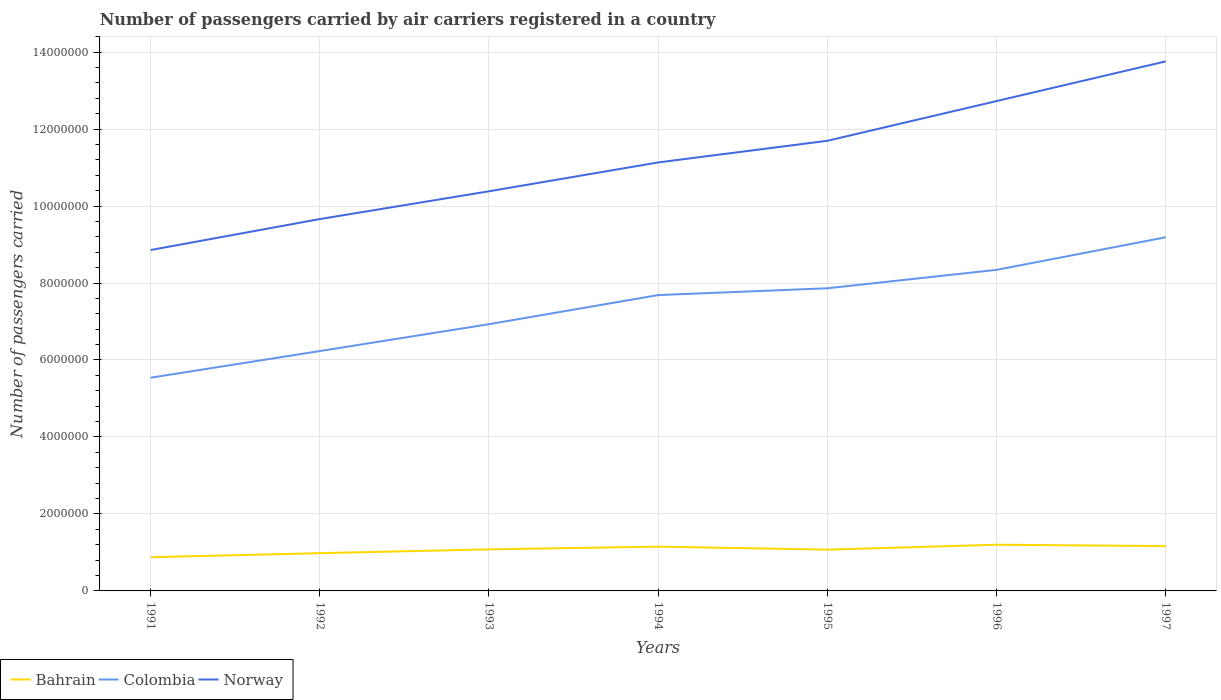How many different coloured lines are there?
Provide a short and direct response. 3. Does the line corresponding to Bahrain intersect with the line corresponding to Norway?
Your response must be concise. No. Across all years, what is the maximum number of passengers carried by air carriers in Norway?
Your answer should be compact. 8.86e+06. What is the total number of passengers carried by air carriers in Bahrain in the graph?
Provide a succinct answer. 3.57e+04. What is the difference between the highest and the second highest number of passengers carried by air carriers in Bahrain?
Provide a short and direct response. 3.25e+05. What is the difference between the highest and the lowest number of passengers carried by air carriers in Colombia?
Offer a terse response. 4. Is the number of passengers carried by air carriers in Norway strictly greater than the number of passengers carried by air carriers in Bahrain over the years?
Your answer should be very brief. No. How many lines are there?
Provide a short and direct response. 3. How many years are there in the graph?
Your answer should be very brief. 7. Does the graph contain any zero values?
Ensure brevity in your answer.  No. Does the graph contain grids?
Offer a very short reply. Yes. How are the legend labels stacked?
Your answer should be very brief. Horizontal. What is the title of the graph?
Provide a short and direct response. Number of passengers carried by air carriers registered in a country. Does "Greece" appear as one of the legend labels in the graph?
Make the answer very short. No. What is the label or title of the X-axis?
Your answer should be very brief. Years. What is the label or title of the Y-axis?
Keep it short and to the point. Number of passengers carried. What is the Number of passengers carried of Bahrain in 1991?
Your answer should be compact. 8.76e+05. What is the Number of passengers carried in Colombia in 1991?
Ensure brevity in your answer.  5.54e+06. What is the Number of passengers carried in Norway in 1991?
Offer a very short reply. 8.86e+06. What is the Number of passengers carried of Bahrain in 1992?
Keep it short and to the point. 9.81e+05. What is the Number of passengers carried of Colombia in 1992?
Your answer should be compact. 6.23e+06. What is the Number of passengers carried in Norway in 1992?
Your response must be concise. 9.66e+06. What is the Number of passengers carried in Bahrain in 1993?
Ensure brevity in your answer.  1.08e+06. What is the Number of passengers carried of Colombia in 1993?
Your answer should be very brief. 6.93e+06. What is the Number of passengers carried of Norway in 1993?
Your response must be concise. 1.04e+07. What is the Number of passengers carried of Bahrain in 1994?
Ensure brevity in your answer.  1.15e+06. What is the Number of passengers carried of Colombia in 1994?
Offer a terse response. 7.69e+06. What is the Number of passengers carried in Norway in 1994?
Your response must be concise. 1.11e+07. What is the Number of passengers carried in Bahrain in 1995?
Offer a terse response. 1.07e+06. What is the Number of passengers carried in Colombia in 1995?
Offer a terse response. 7.86e+06. What is the Number of passengers carried of Norway in 1995?
Ensure brevity in your answer.  1.17e+07. What is the Number of passengers carried in Bahrain in 1996?
Give a very brief answer. 1.20e+06. What is the Number of passengers carried in Colombia in 1996?
Your response must be concise. 8.34e+06. What is the Number of passengers carried of Norway in 1996?
Your response must be concise. 1.27e+07. What is the Number of passengers carried of Bahrain in 1997?
Your response must be concise. 1.16e+06. What is the Number of passengers carried in Colombia in 1997?
Make the answer very short. 9.19e+06. What is the Number of passengers carried in Norway in 1997?
Give a very brief answer. 1.38e+07. Across all years, what is the maximum Number of passengers carried of Bahrain?
Offer a very short reply. 1.20e+06. Across all years, what is the maximum Number of passengers carried in Colombia?
Keep it short and to the point. 9.19e+06. Across all years, what is the maximum Number of passengers carried of Norway?
Provide a short and direct response. 1.38e+07. Across all years, what is the minimum Number of passengers carried in Bahrain?
Keep it short and to the point. 8.76e+05. Across all years, what is the minimum Number of passengers carried in Colombia?
Your answer should be very brief. 5.54e+06. Across all years, what is the minimum Number of passengers carried of Norway?
Your answer should be very brief. 8.86e+06. What is the total Number of passengers carried in Bahrain in the graph?
Give a very brief answer. 7.52e+06. What is the total Number of passengers carried of Colombia in the graph?
Offer a very short reply. 5.18e+07. What is the total Number of passengers carried in Norway in the graph?
Your answer should be very brief. 7.82e+07. What is the difference between the Number of passengers carried of Bahrain in 1991 and that in 1992?
Keep it short and to the point. -1.06e+05. What is the difference between the Number of passengers carried of Colombia in 1991 and that in 1992?
Your response must be concise. -6.92e+05. What is the difference between the Number of passengers carried of Norway in 1991 and that in 1992?
Give a very brief answer. -8.04e+05. What is the difference between the Number of passengers carried in Bahrain in 1991 and that in 1993?
Ensure brevity in your answer.  -2.04e+05. What is the difference between the Number of passengers carried in Colombia in 1991 and that in 1993?
Offer a very short reply. -1.39e+06. What is the difference between the Number of passengers carried in Norway in 1991 and that in 1993?
Offer a very short reply. -1.53e+06. What is the difference between the Number of passengers carried in Bahrain in 1991 and that in 1994?
Your answer should be compact. -2.75e+05. What is the difference between the Number of passengers carried in Colombia in 1991 and that in 1994?
Provide a short and direct response. -2.15e+06. What is the difference between the Number of passengers carried of Norway in 1991 and that in 1994?
Offer a very short reply. -2.28e+06. What is the difference between the Number of passengers carried of Bahrain in 1991 and that in 1995?
Give a very brief answer. -1.97e+05. What is the difference between the Number of passengers carried in Colombia in 1991 and that in 1995?
Give a very brief answer. -2.32e+06. What is the difference between the Number of passengers carried in Norway in 1991 and that in 1995?
Offer a terse response. -2.84e+06. What is the difference between the Number of passengers carried of Bahrain in 1991 and that in 1996?
Ensure brevity in your answer.  -3.25e+05. What is the difference between the Number of passengers carried in Colombia in 1991 and that in 1996?
Ensure brevity in your answer.  -2.80e+06. What is the difference between the Number of passengers carried of Norway in 1991 and that in 1996?
Your response must be concise. -3.87e+06. What is the difference between the Number of passengers carried of Bahrain in 1991 and that in 1997?
Ensure brevity in your answer.  -2.89e+05. What is the difference between the Number of passengers carried in Colombia in 1991 and that in 1997?
Offer a very short reply. -3.65e+06. What is the difference between the Number of passengers carried of Norway in 1991 and that in 1997?
Your answer should be very brief. -4.90e+06. What is the difference between the Number of passengers carried in Bahrain in 1992 and that in 1993?
Ensure brevity in your answer.  -9.89e+04. What is the difference between the Number of passengers carried of Colombia in 1992 and that in 1993?
Your answer should be compact. -6.98e+05. What is the difference between the Number of passengers carried of Norway in 1992 and that in 1993?
Keep it short and to the point. -7.22e+05. What is the difference between the Number of passengers carried in Bahrain in 1992 and that in 1994?
Offer a very short reply. -1.70e+05. What is the difference between the Number of passengers carried in Colombia in 1992 and that in 1994?
Your answer should be very brief. -1.45e+06. What is the difference between the Number of passengers carried of Norway in 1992 and that in 1994?
Your answer should be very brief. -1.47e+06. What is the difference between the Number of passengers carried in Bahrain in 1992 and that in 1995?
Ensure brevity in your answer.  -9.14e+04. What is the difference between the Number of passengers carried of Colombia in 1992 and that in 1995?
Your response must be concise. -1.63e+06. What is the difference between the Number of passengers carried in Norway in 1992 and that in 1995?
Keep it short and to the point. -2.03e+06. What is the difference between the Number of passengers carried in Bahrain in 1992 and that in 1996?
Your response must be concise. -2.19e+05. What is the difference between the Number of passengers carried of Colombia in 1992 and that in 1996?
Your answer should be very brief. -2.11e+06. What is the difference between the Number of passengers carried in Norway in 1992 and that in 1996?
Ensure brevity in your answer.  -3.07e+06. What is the difference between the Number of passengers carried in Bahrain in 1992 and that in 1997?
Provide a succinct answer. -1.84e+05. What is the difference between the Number of passengers carried in Colombia in 1992 and that in 1997?
Your answer should be compact. -2.96e+06. What is the difference between the Number of passengers carried of Norway in 1992 and that in 1997?
Offer a very short reply. -4.10e+06. What is the difference between the Number of passengers carried in Bahrain in 1993 and that in 1994?
Provide a short and direct response. -7.06e+04. What is the difference between the Number of passengers carried in Colombia in 1993 and that in 1994?
Your answer should be compact. -7.56e+05. What is the difference between the Number of passengers carried in Norway in 1993 and that in 1994?
Offer a terse response. -7.50e+05. What is the difference between the Number of passengers carried in Bahrain in 1993 and that in 1995?
Provide a succinct answer. 7500. What is the difference between the Number of passengers carried in Colombia in 1993 and that in 1995?
Your response must be concise. -9.33e+05. What is the difference between the Number of passengers carried in Norway in 1993 and that in 1995?
Your answer should be compact. -1.31e+06. What is the difference between the Number of passengers carried of Bahrain in 1993 and that in 1996?
Keep it short and to the point. -1.20e+05. What is the difference between the Number of passengers carried in Colombia in 1993 and that in 1996?
Give a very brief answer. -1.41e+06. What is the difference between the Number of passengers carried in Norway in 1993 and that in 1996?
Your response must be concise. -2.34e+06. What is the difference between the Number of passengers carried of Bahrain in 1993 and that in 1997?
Provide a succinct answer. -8.46e+04. What is the difference between the Number of passengers carried of Colombia in 1993 and that in 1997?
Your answer should be very brief. -2.26e+06. What is the difference between the Number of passengers carried in Norway in 1993 and that in 1997?
Your answer should be compact. -3.38e+06. What is the difference between the Number of passengers carried of Bahrain in 1994 and that in 1995?
Give a very brief answer. 7.81e+04. What is the difference between the Number of passengers carried of Colombia in 1994 and that in 1995?
Ensure brevity in your answer.  -1.77e+05. What is the difference between the Number of passengers carried in Norway in 1994 and that in 1995?
Give a very brief answer. -5.62e+05. What is the difference between the Number of passengers carried in Bahrain in 1994 and that in 1996?
Provide a succinct answer. -4.97e+04. What is the difference between the Number of passengers carried in Colombia in 1994 and that in 1996?
Your response must be concise. -6.56e+05. What is the difference between the Number of passengers carried of Norway in 1994 and that in 1996?
Your answer should be very brief. -1.59e+06. What is the difference between the Number of passengers carried in Bahrain in 1994 and that in 1997?
Your answer should be very brief. -1.40e+04. What is the difference between the Number of passengers carried of Colombia in 1994 and that in 1997?
Your answer should be very brief. -1.50e+06. What is the difference between the Number of passengers carried of Norway in 1994 and that in 1997?
Make the answer very short. -2.63e+06. What is the difference between the Number of passengers carried in Bahrain in 1995 and that in 1996?
Ensure brevity in your answer.  -1.28e+05. What is the difference between the Number of passengers carried of Colombia in 1995 and that in 1996?
Your response must be concise. -4.79e+05. What is the difference between the Number of passengers carried of Norway in 1995 and that in 1996?
Provide a succinct answer. -1.03e+06. What is the difference between the Number of passengers carried of Bahrain in 1995 and that in 1997?
Your answer should be compact. -9.21e+04. What is the difference between the Number of passengers carried in Colombia in 1995 and that in 1997?
Offer a very short reply. -1.33e+06. What is the difference between the Number of passengers carried in Norway in 1995 and that in 1997?
Your response must be concise. -2.06e+06. What is the difference between the Number of passengers carried of Bahrain in 1996 and that in 1997?
Give a very brief answer. 3.57e+04. What is the difference between the Number of passengers carried in Colombia in 1996 and that in 1997?
Offer a terse response. -8.47e+05. What is the difference between the Number of passengers carried of Norway in 1996 and that in 1997?
Keep it short and to the point. -1.03e+06. What is the difference between the Number of passengers carried of Bahrain in 1991 and the Number of passengers carried of Colombia in 1992?
Offer a very short reply. -5.36e+06. What is the difference between the Number of passengers carried in Bahrain in 1991 and the Number of passengers carried in Norway in 1992?
Offer a terse response. -8.79e+06. What is the difference between the Number of passengers carried in Colombia in 1991 and the Number of passengers carried in Norway in 1992?
Keep it short and to the point. -4.12e+06. What is the difference between the Number of passengers carried of Bahrain in 1991 and the Number of passengers carried of Colombia in 1993?
Keep it short and to the point. -6.05e+06. What is the difference between the Number of passengers carried of Bahrain in 1991 and the Number of passengers carried of Norway in 1993?
Your answer should be compact. -9.51e+06. What is the difference between the Number of passengers carried of Colombia in 1991 and the Number of passengers carried of Norway in 1993?
Give a very brief answer. -4.84e+06. What is the difference between the Number of passengers carried of Bahrain in 1991 and the Number of passengers carried of Colombia in 1994?
Keep it short and to the point. -6.81e+06. What is the difference between the Number of passengers carried in Bahrain in 1991 and the Number of passengers carried in Norway in 1994?
Provide a short and direct response. -1.03e+07. What is the difference between the Number of passengers carried of Colombia in 1991 and the Number of passengers carried of Norway in 1994?
Provide a succinct answer. -5.59e+06. What is the difference between the Number of passengers carried of Bahrain in 1991 and the Number of passengers carried of Colombia in 1995?
Provide a succinct answer. -6.99e+06. What is the difference between the Number of passengers carried of Bahrain in 1991 and the Number of passengers carried of Norway in 1995?
Offer a terse response. -1.08e+07. What is the difference between the Number of passengers carried of Colombia in 1991 and the Number of passengers carried of Norway in 1995?
Your response must be concise. -6.16e+06. What is the difference between the Number of passengers carried in Bahrain in 1991 and the Number of passengers carried in Colombia in 1996?
Provide a succinct answer. -7.47e+06. What is the difference between the Number of passengers carried in Bahrain in 1991 and the Number of passengers carried in Norway in 1996?
Provide a short and direct response. -1.19e+07. What is the difference between the Number of passengers carried of Colombia in 1991 and the Number of passengers carried of Norway in 1996?
Make the answer very short. -7.19e+06. What is the difference between the Number of passengers carried in Bahrain in 1991 and the Number of passengers carried in Colombia in 1997?
Offer a very short reply. -8.31e+06. What is the difference between the Number of passengers carried of Bahrain in 1991 and the Number of passengers carried of Norway in 1997?
Offer a terse response. -1.29e+07. What is the difference between the Number of passengers carried of Colombia in 1991 and the Number of passengers carried of Norway in 1997?
Your answer should be compact. -8.22e+06. What is the difference between the Number of passengers carried in Bahrain in 1992 and the Number of passengers carried in Colombia in 1993?
Offer a very short reply. -5.95e+06. What is the difference between the Number of passengers carried in Bahrain in 1992 and the Number of passengers carried in Norway in 1993?
Your response must be concise. -9.40e+06. What is the difference between the Number of passengers carried of Colombia in 1992 and the Number of passengers carried of Norway in 1993?
Ensure brevity in your answer.  -4.15e+06. What is the difference between the Number of passengers carried in Bahrain in 1992 and the Number of passengers carried in Colombia in 1994?
Offer a terse response. -6.71e+06. What is the difference between the Number of passengers carried in Bahrain in 1992 and the Number of passengers carried in Norway in 1994?
Keep it short and to the point. -1.02e+07. What is the difference between the Number of passengers carried in Colombia in 1992 and the Number of passengers carried in Norway in 1994?
Offer a terse response. -4.90e+06. What is the difference between the Number of passengers carried in Bahrain in 1992 and the Number of passengers carried in Colombia in 1995?
Your answer should be very brief. -6.88e+06. What is the difference between the Number of passengers carried of Bahrain in 1992 and the Number of passengers carried of Norway in 1995?
Offer a terse response. -1.07e+07. What is the difference between the Number of passengers carried of Colombia in 1992 and the Number of passengers carried of Norway in 1995?
Your response must be concise. -5.46e+06. What is the difference between the Number of passengers carried of Bahrain in 1992 and the Number of passengers carried of Colombia in 1996?
Offer a terse response. -7.36e+06. What is the difference between the Number of passengers carried of Bahrain in 1992 and the Number of passengers carried of Norway in 1996?
Your answer should be compact. -1.17e+07. What is the difference between the Number of passengers carried in Colombia in 1992 and the Number of passengers carried in Norway in 1996?
Your response must be concise. -6.50e+06. What is the difference between the Number of passengers carried of Bahrain in 1992 and the Number of passengers carried of Colombia in 1997?
Ensure brevity in your answer.  -8.21e+06. What is the difference between the Number of passengers carried in Bahrain in 1992 and the Number of passengers carried in Norway in 1997?
Offer a very short reply. -1.28e+07. What is the difference between the Number of passengers carried of Colombia in 1992 and the Number of passengers carried of Norway in 1997?
Provide a short and direct response. -7.53e+06. What is the difference between the Number of passengers carried of Bahrain in 1993 and the Number of passengers carried of Colombia in 1994?
Your answer should be compact. -6.61e+06. What is the difference between the Number of passengers carried of Bahrain in 1993 and the Number of passengers carried of Norway in 1994?
Give a very brief answer. -1.01e+07. What is the difference between the Number of passengers carried of Colombia in 1993 and the Number of passengers carried of Norway in 1994?
Give a very brief answer. -4.20e+06. What is the difference between the Number of passengers carried of Bahrain in 1993 and the Number of passengers carried of Colombia in 1995?
Your answer should be very brief. -6.78e+06. What is the difference between the Number of passengers carried of Bahrain in 1993 and the Number of passengers carried of Norway in 1995?
Offer a terse response. -1.06e+07. What is the difference between the Number of passengers carried of Colombia in 1993 and the Number of passengers carried of Norway in 1995?
Keep it short and to the point. -4.77e+06. What is the difference between the Number of passengers carried in Bahrain in 1993 and the Number of passengers carried in Colombia in 1996?
Your answer should be very brief. -7.26e+06. What is the difference between the Number of passengers carried in Bahrain in 1993 and the Number of passengers carried in Norway in 1996?
Your response must be concise. -1.16e+07. What is the difference between the Number of passengers carried in Colombia in 1993 and the Number of passengers carried in Norway in 1996?
Provide a succinct answer. -5.80e+06. What is the difference between the Number of passengers carried of Bahrain in 1993 and the Number of passengers carried of Colombia in 1997?
Your answer should be very brief. -8.11e+06. What is the difference between the Number of passengers carried in Bahrain in 1993 and the Number of passengers carried in Norway in 1997?
Your response must be concise. -1.27e+07. What is the difference between the Number of passengers carried of Colombia in 1993 and the Number of passengers carried of Norway in 1997?
Provide a succinct answer. -6.83e+06. What is the difference between the Number of passengers carried of Bahrain in 1994 and the Number of passengers carried of Colombia in 1995?
Offer a terse response. -6.71e+06. What is the difference between the Number of passengers carried in Bahrain in 1994 and the Number of passengers carried in Norway in 1995?
Offer a terse response. -1.05e+07. What is the difference between the Number of passengers carried of Colombia in 1994 and the Number of passengers carried of Norway in 1995?
Give a very brief answer. -4.01e+06. What is the difference between the Number of passengers carried in Bahrain in 1994 and the Number of passengers carried in Colombia in 1996?
Your answer should be compact. -7.19e+06. What is the difference between the Number of passengers carried in Bahrain in 1994 and the Number of passengers carried in Norway in 1996?
Provide a short and direct response. -1.16e+07. What is the difference between the Number of passengers carried of Colombia in 1994 and the Number of passengers carried of Norway in 1996?
Give a very brief answer. -5.04e+06. What is the difference between the Number of passengers carried in Bahrain in 1994 and the Number of passengers carried in Colombia in 1997?
Offer a terse response. -8.04e+06. What is the difference between the Number of passengers carried in Bahrain in 1994 and the Number of passengers carried in Norway in 1997?
Provide a short and direct response. -1.26e+07. What is the difference between the Number of passengers carried of Colombia in 1994 and the Number of passengers carried of Norway in 1997?
Give a very brief answer. -6.07e+06. What is the difference between the Number of passengers carried of Bahrain in 1995 and the Number of passengers carried of Colombia in 1996?
Offer a very short reply. -7.27e+06. What is the difference between the Number of passengers carried in Bahrain in 1995 and the Number of passengers carried in Norway in 1996?
Give a very brief answer. -1.17e+07. What is the difference between the Number of passengers carried in Colombia in 1995 and the Number of passengers carried in Norway in 1996?
Your answer should be very brief. -4.86e+06. What is the difference between the Number of passengers carried of Bahrain in 1995 and the Number of passengers carried of Colombia in 1997?
Provide a short and direct response. -8.12e+06. What is the difference between the Number of passengers carried of Bahrain in 1995 and the Number of passengers carried of Norway in 1997?
Your answer should be very brief. -1.27e+07. What is the difference between the Number of passengers carried in Colombia in 1995 and the Number of passengers carried in Norway in 1997?
Ensure brevity in your answer.  -5.90e+06. What is the difference between the Number of passengers carried in Bahrain in 1996 and the Number of passengers carried in Colombia in 1997?
Provide a succinct answer. -7.99e+06. What is the difference between the Number of passengers carried in Bahrain in 1996 and the Number of passengers carried in Norway in 1997?
Keep it short and to the point. -1.26e+07. What is the difference between the Number of passengers carried of Colombia in 1996 and the Number of passengers carried of Norway in 1997?
Offer a terse response. -5.42e+06. What is the average Number of passengers carried in Bahrain per year?
Your response must be concise. 1.07e+06. What is the average Number of passengers carried of Colombia per year?
Keep it short and to the point. 7.40e+06. What is the average Number of passengers carried of Norway per year?
Give a very brief answer. 1.12e+07. In the year 1991, what is the difference between the Number of passengers carried of Bahrain and Number of passengers carried of Colombia?
Provide a succinct answer. -4.66e+06. In the year 1991, what is the difference between the Number of passengers carried of Bahrain and Number of passengers carried of Norway?
Your answer should be very brief. -7.98e+06. In the year 1991, what is the difference between the Number of passengers carried of Colombia and Number of passengers carried of Norway?
Ensure brevity in your answer.  -3.32e+06. In the year 1992, what is the difference between the Number of passengers carried of Bahrain and Number of passengers carried of Colombia?
Your answer should be very brief. -5.25e+06. In the year 1992, what is the difference between the Number of passengers carried in Bahrain and Number of passengers carried in Norway?
Ensure brevity in your answer.  -8.68e+06. In the year 1992, what is the difference between the Number of passengers carried of Colombia and Number of passengers carried of Norway?
Your answer should be very brief. -3.43e+06. In the year 1993, what is the difference between the Number of passengers carried in Bahrain and Number of passengers carried in Colombia?
Provide a succinct answer. -5.85e+06. In the year 1993, what is the difference between the Number of passengers carried of Bahrain and Number of passengers carried of Norway?
Your answer should be very brief. -9.30e+06. In the year 1993, what is the difference between the Number of passengers carried of Colombia and Number of passengers carried of Norway?
Give a very brief answer. -3.45e+06. In the year 1994, what is the difference between the Number of passengers carried of Bahrain and Number of passengers carried of Colombia?
Your answer should be very brief. -6.54e+06. In the year 1994, what is the difference between the Number of passengers carried of Bahrain and Number of passengers carried of Norway?
Provide a short and direct response. -9.98e+06. In the year 1994, what is the difference between the Number of passengers carried in Colombia and Number of passengers carried in Norway?
Make the answer very short. -3.45e+06. In the year 1995, what is the difference between the Number of passengers carried of Bahrain and Number of passengers carried of Colombia?
Offer a terse response. -6.79e+06. In the year 1995, what is the difference between the Number of passengers carried in Bahrain and Number of passengers carried in Norway?
Provide a short and direct response. -1.06e+07. In the year 1995, what is the difference between the Number of passengers carried in Colombia and Number of passengers carried in Norway?
Make the answer very short. -3.83e+06. In the year 1996, what is the difference between the Number of passengers carried of Bahrain and Number of passengers carried of Colombia?
Offer a terse response. -7.14e+06. In the year 1996, what is the difference between the Number of passengers carried of Bahrain and Number of passengers carried of Norway?
Keep it short and to the point. -1.15e+07. In the year 1996, what is the difference between the Number of passengers carried of Colombia and Number of passengers carried of Norway?
Offer a terse response. -4.39e+06. In the year 1997, what is the difference between the Number of passengers carried of Bahrain and Number of passengers carried of Colombia?
Provide a succinct answer. -8.02e+06. In the year 1997, what is the difference between the Number of passengers carried in Bahrain and Number of passengers carried in Norway?
Your response must be concise. -1.26e+07. In the year 1997, what is the difference between the Number of passengers carried of Colombia and Number of passengers carried of Norway?
Your response must be concise. -4.57e+06. What is the ratio of the Number of passengers carried of Bahrain in 1991 to that in 1992?
Make the answer very short. 0.89. What is the ratio of the Number of passengers carried of Colombia in 1991 to that in 1992?
Give a very brief answer. 0.89. What is the ratio of the Number of passengers carried of Norway in 1991 to that in 1992?
Provide a succinct answer. 0.92. What is the ratio of the Number of passengers carried of Bahrain in 1991 to that in 1993?
Ensure brevity in your answer.  0.81. What is the ratio of the Number of passengers carried of Colombia in 1991 to that in 1993?
Provide a succinct answer. 0.8. What is the ratio of the Number of passengers carried in Norway in 1991 to that in 1993?
Ensure brevity in your answer.  0.85. What is the ratio of the Number of passengers carried of Bahrain in 1991 to that in 1994?
Keep it short and to the point. 0.76. What is the ratio of the Number of passengers carried of Colombia in 1991 to that in 1994?
Your answer should be compact. 0.72. What is the ratio of the Number of passengers carried in Norway in 1991 to that in 1994?
Offer a very short reply. 0.8. What is the ratio of the Number of passengers carried of Bahrain in 1991 to that in 1995?
Ensure brevity in your answer.  0.82. What is the ratio of the Number of passengers carried of Colombia in 1991 to that in 1995?
Provide a short and direct response. 0.7. What is the ratio of the Number of passengers carried in Norway in 1991 to that in 1995?
Offer a very short reply. 0.76. What is the ratio of the Number of passengers carried of Bahrain in 1991 to that in 1996?
Your answer should be compact. 0.73. What is the ratio of the Number of passengers carried of Colombia in 1991 to that in 1996?
Provide a short and direct response. 0.66. What is the ratio of the Number of passengers carried of Norway in 1991 to that in 1996?
Make the answer very short. 0.7. What is the ratio of the Number of passengers carried in Bahrain in 1991 to that in 1997?
Your answer should be compact. 0.75. What is the ratio of the Number of passengers carried of Colombia in 1991 to that in 1997?
Your answer should be compact. 0.6. What is the ratio of the Number of passengers carried of Norway in 1991 to that in 1997?
Provide a short and direct response. 0.64. What is the ratio of the Number of passengers carried of Bahrain in 1992 to that in 1993?
Your response must be concise. 0.91. What is the ratio of the Number of passengers carried of Colombia in 1992 to that in 1993?
Give a very brief answer. 0.9. What is the ratio of the Number of passengers carried of Norway in 1992 to that in 1993?
Your answer should be very brief. 0.93. What is the ratio of the Number of passengers carried in Bahrain in 1992 to that in 1994?
Give a very brief answer. 0.85. What is the ratio of the Number of passengers carried of Colombia in 1992 to that in 1994?
Your answer should be compact. 0.81. What is the ratio of the Number of passengers carried of Norway in 1992 to that in 1994?
Provide a succinct answer. 0.87. What is the ratio of the Number of passengers carried in Bahrain in 1992 to that in 1995?
Your answer should be very brief. 0.91. What is the ratio of the Number of passengers carried of Colombia in 1992 to that in 1995?
Your answer should be very brief. 0.79. What is the ratio of the Number of passengers carried in Norway in 1992 to that in 1995?
Provide a short and direct response. 0.83. What is the ratio of the Number of passengers carried in Bahrain in 1992 to that in 1996?
Give a very brief answer. 0.82. What is the ratio of the Number of passengers carried of Colombia in 1992 to that in 1996?
Your answer should be very brief. 0.75. What is the ratio of the Number of passengers carried of Norway in 1992 to that in 1996?
Offer a terse response. 0.76. What is the ratio of the Number of passengers carried of Bahrain in 1992 to that in 1997?
Offer a terse response. 0.84. What is the ratio of the Number of passengers carried of Colombia in 1992 to that in 1997?
Make the answer very short. 0.68. What is the ratio of the Number of passengers carried of Norway in 1992 to that in 1997?
Keep it short and to the point. 0.7. What is the ratio of the Number of passengers carried in Bahrain in 1993 to that in 1994?
Ensure brevity in your answer.  0.94. What is the ratio of the Number of passengers carried of Colombia in 1993 to that in 1994?
Make the answer very short. 0.9. What is the ratio of the Number of passengers carried in Norway in 1993 to that in 1994?
Your response must be concise. 0.93. What is the ratio of the Number of passengers carried in Bahrain in 1993 to that in 1995?
Keep it short and to the point. 1.01. What is the ratio of the Number of passengers carried in Colombia in 1993 to that in 1995?
Make the answer very short. 0.88. What is the ratio of the Number of passengers carried in Norway in 1993 to that in 1995?
Your response must be concise. 0.89. What is the ratio of the Number of passengers carried in Bahrain in 1993 to that in 1996?
Make the answer very short. 0.9. What is the ratio of the Number of passengers carried of Colombia in 1993 to that in 1996?
Offer a terse response. 0.83. What is the ratio of the Number of passengers carried in Norway in 1993 to that in 1996?
Offer a terse response. 0.82. What is the ratio of the Number of passengers carried in Bahrain in 1993 to that in 1997?
Offer a very short reply. 0.93. What is the ratio of the Number of passengers carried in Colombia in 1993 to that in 1997?
Ensure brevity in your answer.  0.75. What is the ratio of the Number of passengers carried in Norway in 1993 to that in 1997?
Make the answer very short. 0.75. What is the ratio of the Number of passengers carried of Bahrain in 1994 to that in 1995?
Keep it short and to the point. 1.07. What is the ratio of the Number of passengers carried in Colombia in 1994 to that in 1995?
Ensure brevity in your answer.  0.98. What is the ratio of the Number of passengers carried in Norway in 1994 to that in 1995?
Your answer should be very brief. 0.95. What is the ratio of the Number of passengers carried of Bahrain in 1994 to that in 1996?
Offer a very short reply. 0.96. What is the ratio of the Number of passengers carried of Colombia in 1994 to that in 1996?
Your response must be concise. 0.92. What is the ratio of the Number of passengers carried in Norway in 1994 to that in 1996?
Keep it short and to the point. 0.87. What is the ratio of the Number of passengers carried in Colombia in 1994 to that in 1997?
Your answer should be very brief. 0.84. What is the ratio of the Number of passengers carried in Norway in 1994 to that in 1997?
Offer a terse response. 0.81. What is the ratio of the Number of passengers carried in Bahrain in 1995 to that in 1996?
Provide a succinct answer. 0.89. What is the ratio of the Number of passengers carried in Colombia in 1995 to that in 1996?
Provide a short and direct response. 0.94. What is the ratio of the Number of passengers carried of Norway in 1995 to that in 1996?
Make the answer very short. 0.92. What is the ratio of the Number of passengers carried in Bahrain in 1995 to that in 1997?
Provide a succinct answer. 0.92. What is the ratio of the Number of passengers carried of Colombia in 1995 to that in 1997?
Your response must be concise. 0.86. What is the ratio of the Number of passengers carried in Bahrain in 1996 to that in 1997?
Provide a short and direct response. 1.03. What is the ratio of the Number of passengers carried in Colombia in 1996 to that in 1997?
Provide a short and direct response. 0.91. What is the ratio of the Number of passengers carried in Norway in 1996 to that in 1997?
Your answer should be very brief. 0.93. What is the difference between the highest and the second highest Number of passengers carried in Bahrain?
Your answer should be compact. 3.57e+04. What is the difference between the highest and the second highest Number of passengers carried in Colombia?
Keep it short and to the point. 8.47e+05. What is the difference between the highest and the second highest Number of passengers carried of Norway?
Ensure brevity in your answer.  1.03e+06. What is the difference between the highest and the lowest Number of passengers carried of Bahrain?
Your answer should be very brief. 3.25e+05. What is the difference between the highest and the lowest Number of passengers carried in Colombia?
Your answer should be compact. 3.65e+06. What is the difference between the highest and the lowest Number of passengers carried in Norway?
Provide a short and direct response. 4.90e+06. 